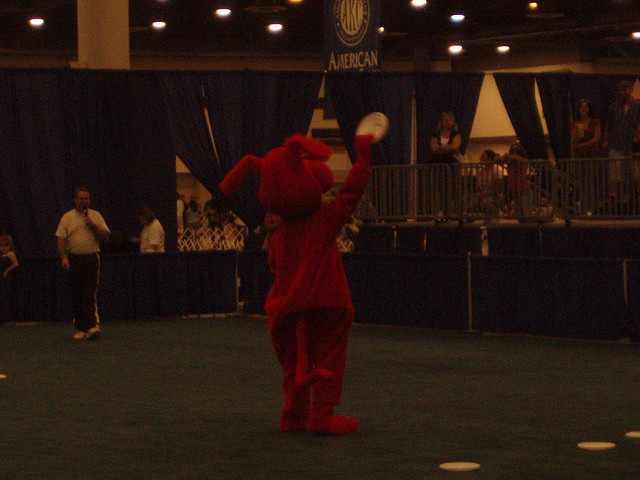Describe the objects in this image and their specific colors. I can see people in black, maroon, and brown tones, people in black and maroon tones, people in black, maroon, and brown tones, people in black, maroon, and brown tones, and people in black, maroon, and brown tones in this image. 